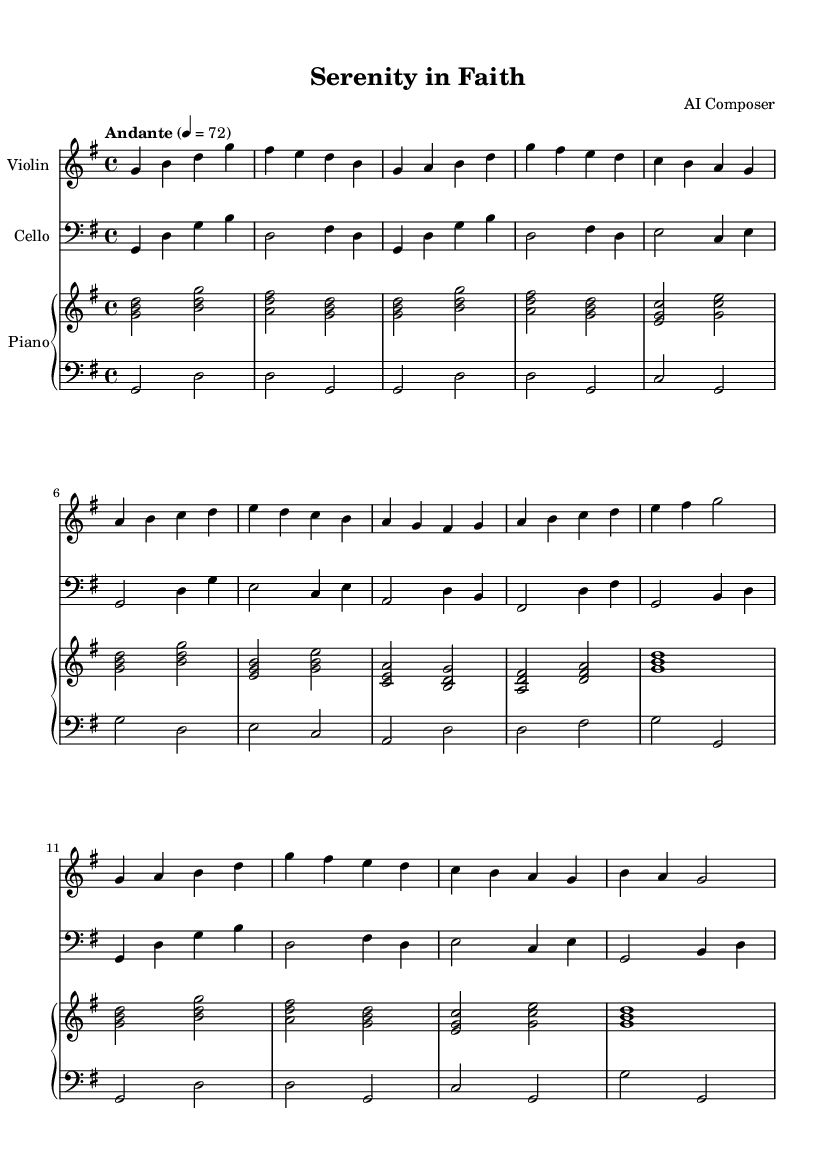What is the key signature of this music? The key signature is indicated at the beginning of the staff. In this piece, it is G major, which has one sharp (F#).
Answer: G major What is the time signature of this piece? The time signature is specified directly after the key signature. Here, it is 4/4, meaning there are four beats in a measure, and the quarter note gets one beat.
Answer: 4/4 What is the tempo marking given for this music? The tempo can be found at the beginning of the score. It is marked as "Andante," which indicates a moderate walking pace.
Answer: Andante What instruments are featured in this composition? The instruments are listed above the staves in the score. This piece features a Violin, Cello, and Piano.
Answer: Violin, Cello, Piano Which section of the music includes the notes E, D, and C in sequence? To answer this, one must look at the sections labeled A and B. The B section contains the notes E, D, and C in succession, specifically in the measures defined for the B section.
Answer: B section How many measures are in the A section? Count the measures in the A section detailed in the score. The A section has a total of 4 measures.
Answer: 4 What is the dynamic marking at the beginning of the score? The dynamic marking provides guidance on volume, but in this score, there isn't a specific dynamic notation included in the provided data. However, it may denote a gentle touch as implied by "Andante."
Answer: Not specified 